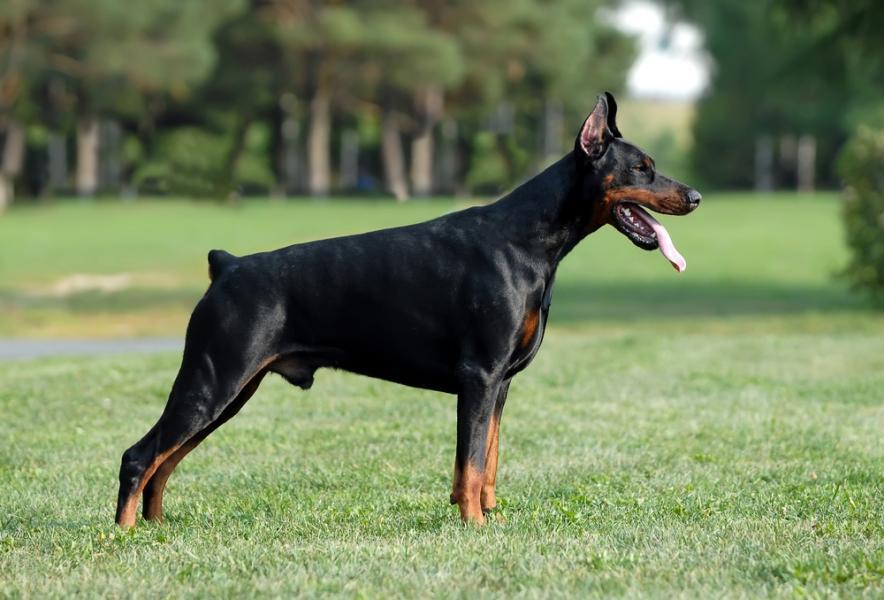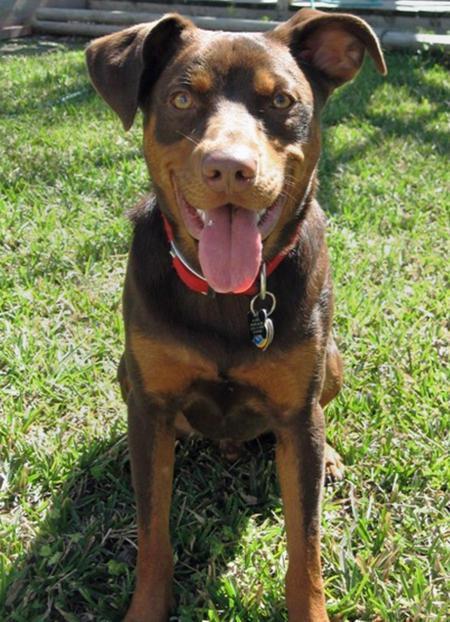The first image is the image on the left, the second image is the image on the right. Assess this claim about the two images: "One of the dobermans pictures has a black coat and one has a brown coat.". Correct or not? Answer yes or no. Yes. The first image is the image on the left, the second image is the image on the right. Evaluate the accuracy of this statement regarding the images: "All of the dogs are facing directly to the camera.". Is it true? Answer yes or no. No. 